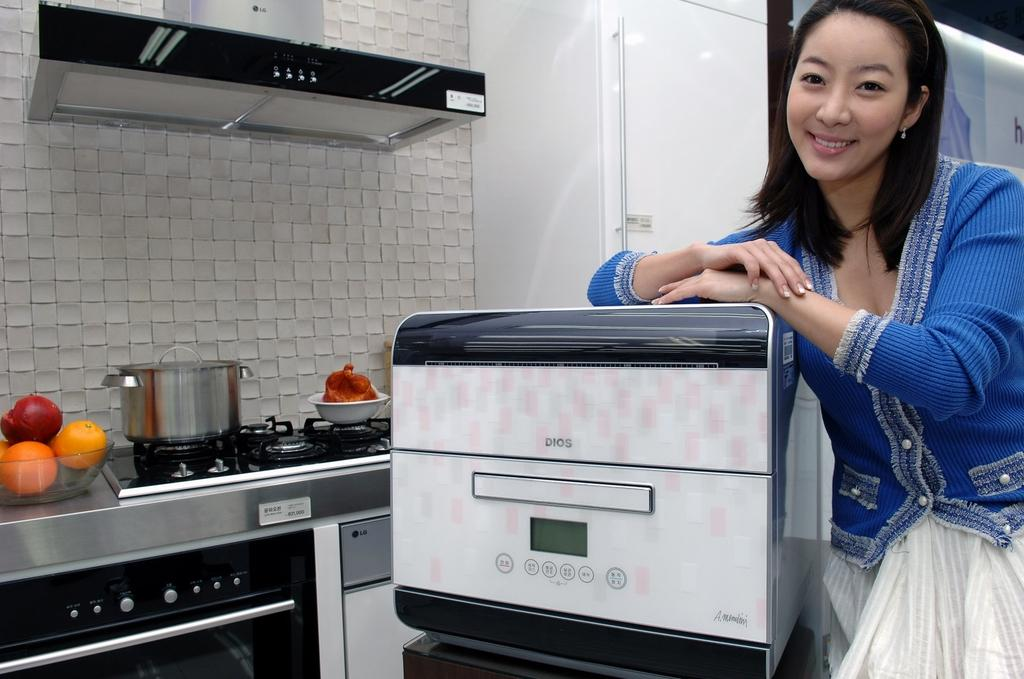Who is present in the image? There is a woman in the image. What appliance is near the woman? The woman is standing near a microwave oven. What other cooking appliance is visible in the image? There is a stove in the image. What is in the bowl that can be seen in the image? The bowl contains fruits. What is the tall structure visible in the image? There is a chimney in the image. What type of star can be seen shining brightly in the image? There is no star visible in the image. How much sugar is in the bowl with fruits? The image does not provide information about the amount of sugar. 